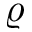Convert formula to latex. <formula><loc_0><loc_0><loc_500><loc_500>\varrho</formula> 